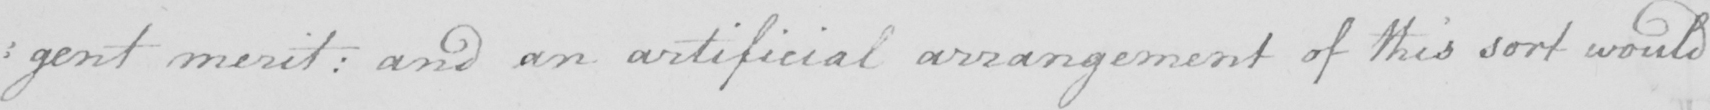Transcribe the text shown in this historical manuscript line. : gent merit :  and an artificial arrangement of this sort would 